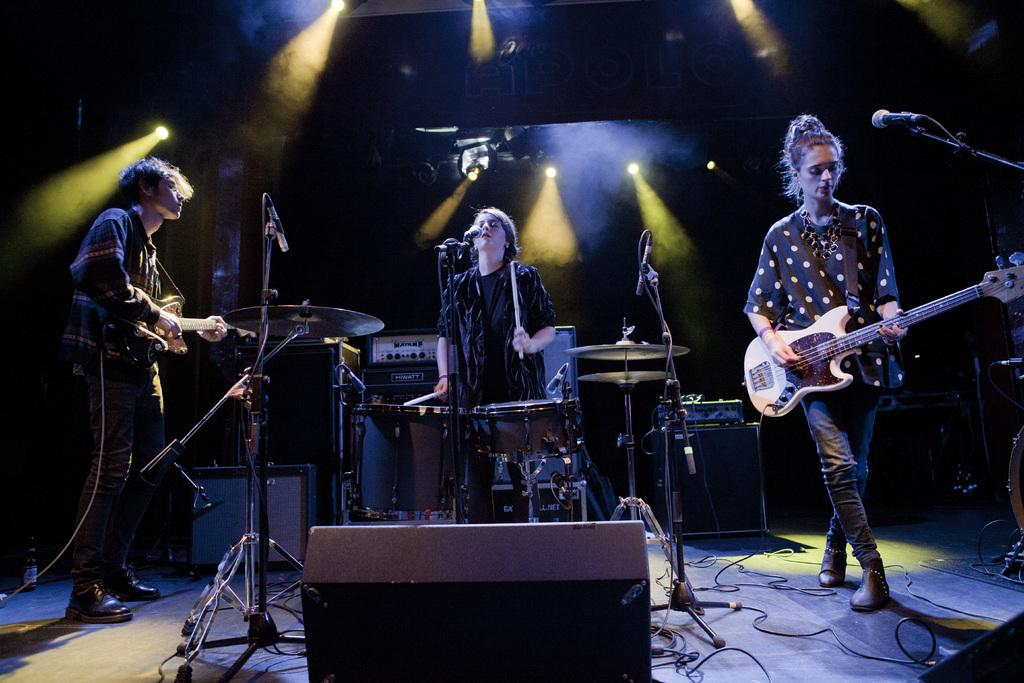What are the people in the image doing? There are people standing in the image, and two of them are holding guitars. What musical instrument can be seen in the image? There is a drum set in the background of the image. What equipment might be used for amplifying sound in the image? There is a microphone in the image. Can you see any steam coming from the guitars in the image? There is no steam coming from the guitars in the image. Is the sea visible in the background of the image? The sea is not visible in the background of the image. 